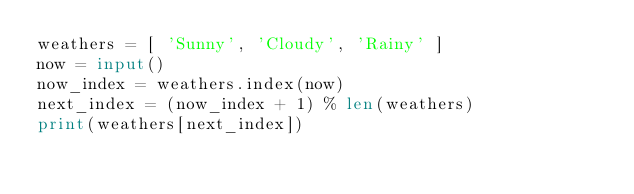<code> <loc_0><loc_0><loc_500><loc_500><_Python_>weathers = [ 'Sunny', 'Cloudy', 'Rainy' ]
now = input()
now_index = weathers.index(now)
next_index = (now_index + 1) % len(weathers)
print(weathers[next_index])
</code> 